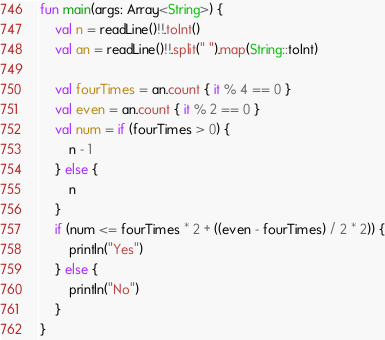Convert code to text. <code><loc_0><loc_0><loc_500><loc_500><_Kotlin_>fun main(args: Array<String>) {
    val n = readLine()!!.toInt()
    val an = readLine()!!.split(" ").map(String::toInt)

    val fourTimes = an.count { it % 4 == 0 }
    val even = an.count { it % 2 == 0 }
    val num = if (fourTimes > 0) {
        n - 1
    } else {
        n
    }
    if (num <= fourTimes * 2 + ((even - fourTimes) / 2 * 2)) {
        println("Yes")
    } else {
        println("No")
    }
}


</code> 